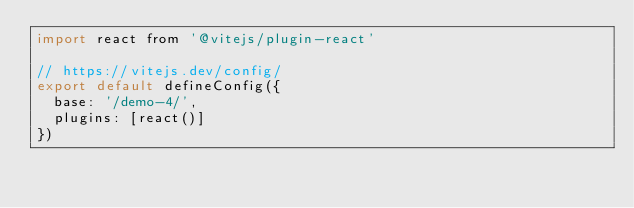<code> <loc_0><loc_0><loc_500><loc_500><_JavaScript_>import react from '@vitejs/plugin-react'

// https://vitejs.dev/config/
export default defineConfig({
  base: '/demo-4/',
  plugins: [react()]
})
</code> 